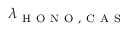<formula> <loc_0><loc_0><loc_500><loc_500>\lambda _ { H O N O , C A S }</formula> 